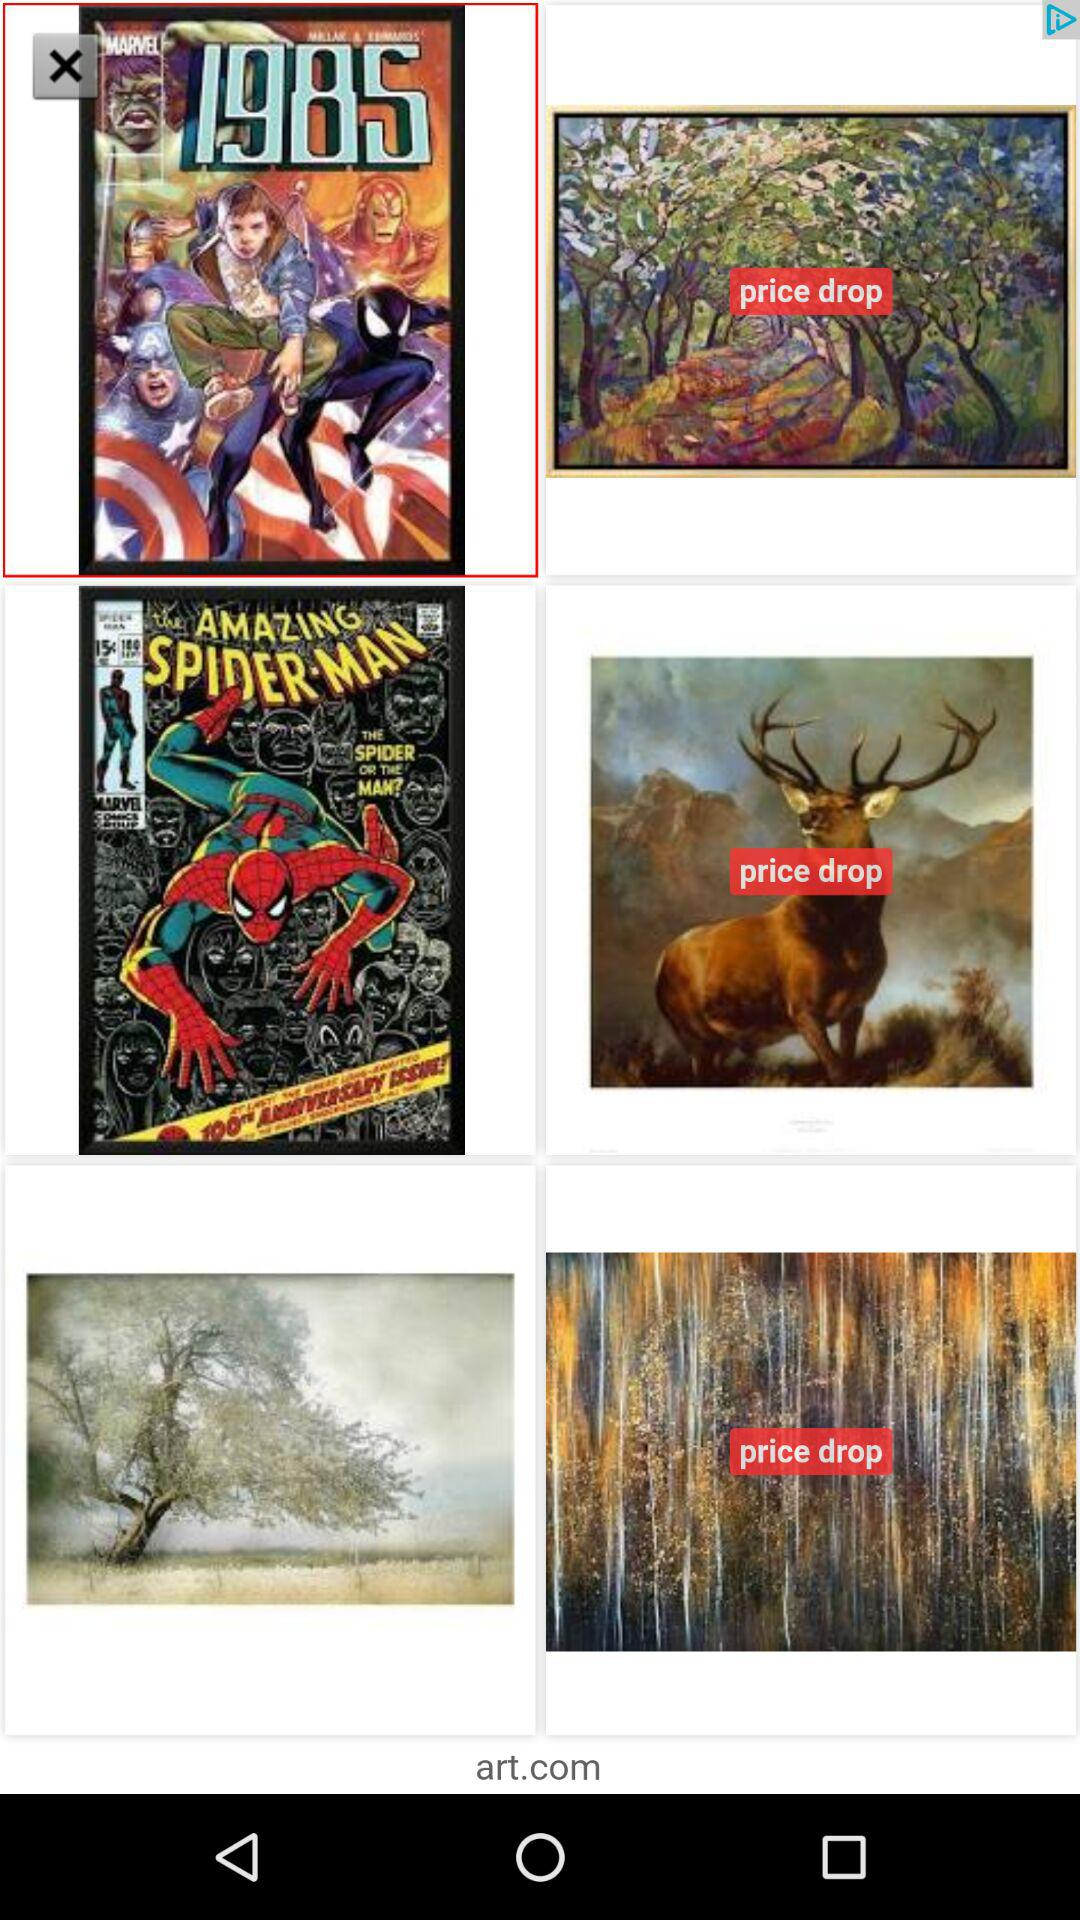How many items have a price drop sign?
Answer the question using a single word or phrase. 3 